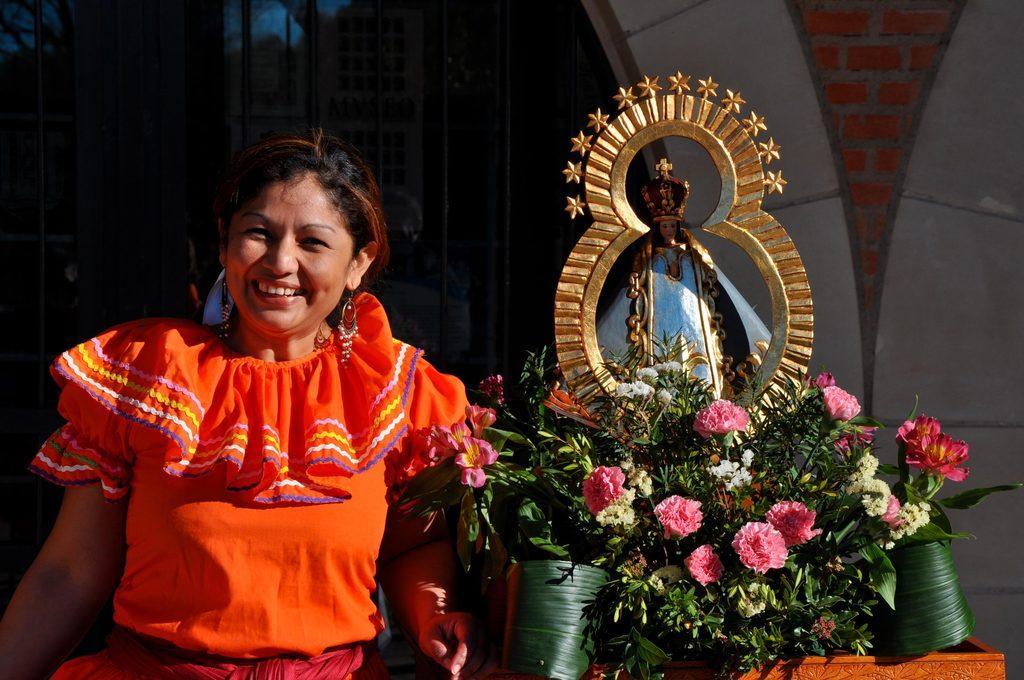In one or two sentences, can you explain what this image depicts? In this image at front there is a person standing on the floor. Beside her there is a plant with the flowers on it. Behind the plant there is a statue. At the back side there is a building. 